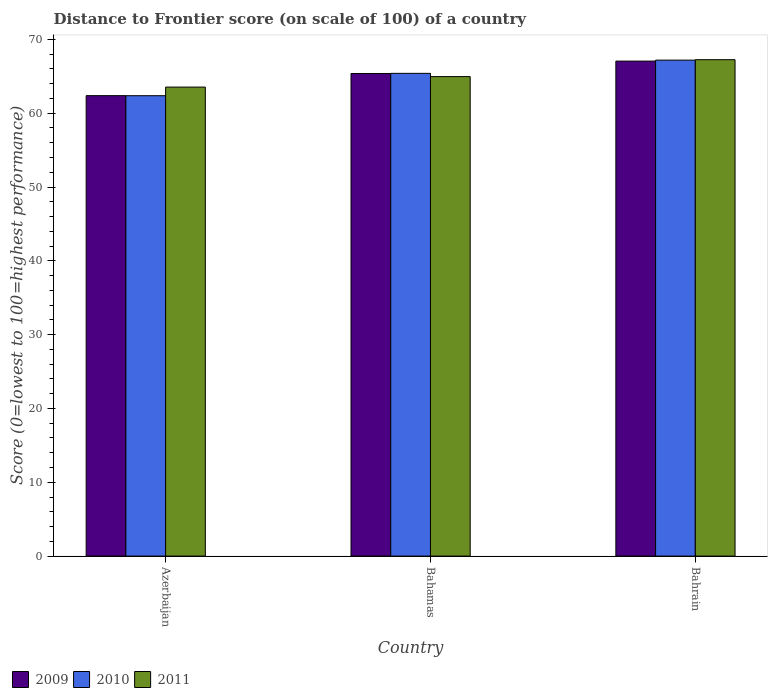How many different coloured bars are there?
Your answer should be very brief. 3. How many groups of bars are there?
Your answer should be very brief. 3. Are the number of bars per tick equal to the number of legend labels?
Give a very brief answer. Yes. Are the number of bars on each tick of the X-axis equal?
Offer a very short reply. Yes. How many bars are there on the 2nd tick from the left?
Ensure brevity in your answer.  3. How many bars are there on the 1st tick from the right?
Offer a very short reply. 3. What is the label of the 1st group of bars from the left?
Provide a succinct answer. Azerbaijan. What is the distance to frontier score of in 2009 in Bahrain?
Provide a succinct answer. 67.06. Across all countries, what is the maximum distance to frontier score of in 2011?
Offer a terse response. 67.25. Across all countries, what is the minimum distance to frontier score of in 2011?
Ensure brevity in your answer.  63.54. In which country was the distance to frontier score of in 2010 maximum?
Keep it short and to the point. Bahrain. In which country was the distance to frontier score of in 2011 minimum?
Ensure brevity in your answer.  Azerbaijan. What is the total distance to frontier score of in 2011 in the graph?
Keep it short and to the point. 195.75. What is the difference between the distance to frontier score of in 2010 in Azerbaijan and that in Bahamas?
Ensure brevity in your answer.  -3.03. What is the difference between the distance to frontier score of in 2011 in Bahrain and the distance to frontier score of in 2009 in Bahamas?
Your answer should be very brief. 1.87. What is the average distance to frontier score of in 2011 per country?
Keep it short and to the point. 65.25. What is the difference between the distance to frontier score of of/in 2010 and distance to frontier score of of/in 2009 in Azerbaijan?
Ensure brevity in your answer.  -0.01. What is the ratio of the distance to frontier score of in 2010 in Bahamas to that in Bahrain?
Provide a succinct answer. 0.97. Is the distance to frontier score of in 2009 in Azerbaijan less than that in Bahrain?
Make the answer very short. Yes. What is the difference between the highest and the second highest distance to frontier score of in 2009?
Offer a terse response. -1.68. What is the difference between the highest and the lowest distance to frontier score of in 2010?
Make the answer very short. 4.82. In how many countries, is the distance to frontier score of in 2010 greater than the average distance to frontier score of in 2010 taken over all countries?
Your answer should be compact. 2. Is the sum of the distance to frontier score of in 2011 in Bahamas and Bahrain greater than the maximum distance to frontier score of in 2010 across all countries?
Keep it short and to the point. Yes. What does the 2nd bar from the left in Azerbaijan represents?
Your answer should be compact. 2010. Is it the case that in every country, the sum of the distance to frontier score of in 2009 and distance to frontier score of in 2010 is greater than the distance to frontier score of in 2011?
Provide a short and direct response. Yes. Are all the bars in the graph horizontal?
Provide a short and direct response. No. Where does the legend appear in the graph?
Your response must be concise. Bottom left. How many legend labels are there?
Your answer should be very brief. 3. What is the title of the graph?
Your answer should be very brief. Distance to Frontier score (on scale of 100) of a country. Does "2009" appear as one of the legend labels in the graph?
Provide a succinct answer. Yes. What is the label or title of the X-axis?
Make the answer very short. Country. What is the label or title of the Y-axis?
Provide a short and direct response. Score (0=lowest to 100=highest performance). What is the Score (0=lowest to 100=highest performance) of 2009 in Azerbaijan?
Provide a short and direct response. 62.38. What is the Score (0=lowest to 100=highest performance) in 2010 in Azerbaijan?
Keep it short and to the point. 62.37. What is the Score (0=lowest to 100=highest performance) in 2011 in Azerbaijan?
Ensure brevity in your answer.  63.54. What is the Score (0=lowest to 100=highest performance) in 2009 in Bahamas?
Provide a succinct answer. 65.38. What is the Score (0=lowest to 100=highest performance) of 2010 in Bahamas?
Provide a short and direct response. 65.4. What is the Score (0=lowest to 100=highest performance) of 2011 in Bahamas?
Keep it short and to the point. 64.96. What is the Score (0=lowest to 100=highest performance) in 2009 in Bahrain?
Your response must be concise. 67.06. What is the Score (0=lowest to 100=highest performance) in 2010 in Bahrain?
Provide a short and direct response. 67.19. What is the Score (0=lowest to 100=highest performance) of 2011 in Bahrain?
Your answer should be compact. 67.25. Across all countries, what is the maximum Score (0=lowest to 100=highest performance) of 2009?
Provide a succinct answer. 67.06. Across all countries, what is the maximum Score (0=lowest to 100=highest performance) in 2010?
Provide a short and direct response. 67.19. Across all countries, what is the maximum Score (0=lowest to 100=highest performance) of 2011?
Ensure brevity in your answer.  67.25. Across all countries, what is the minimum Score (0=lowest to 100=highest performance) in 2009?
Ensure brevity in your answer.  62.38. Across all countries, what is the minimum Score (0=lowest to 100=highest performance) of 2010?
Give a very brief answer. 62.37. Across all countries, what is the minimum Score (0=lowest to 100=highest performance) in 2011?
Make the answer very short. 63.54. What is the total Score (0=lowest to 100=highest performance) of 2009 in the graph?
Your answer should be compact. 194.82. What is the total Score (0=lowest to 100=highest performance) of 2010 in the graph?
Ensure brevity in your answer.  194.96. What is the total Score (0=lowest to 100=highest performance) of 2011 in the graph?
Keep it short and to the point. 195.75. What is the difference between the Score (0=lowest to 100=highest performance) of 2010 in Azerbaijan and that in Bahamas?
Make the answer very short. -3.03. What is the difference between the Score (0=lowest to 100=highest performance) of 2011 in Azerbaijan and that in Bahamas?
Provide a short and direct response. -1.42. What is the difference between the Score (0=lowest to 100=highest performance) of 2009 in Azerbaijan and that in Bahrain?
Make the answer very short. -4.68. What is the difference between the Score (0=lowest to 100=highest performance) in 2010 in Azerbaijan and that in Bahrain?
Give a very brief answer. -4.82. What is the difference between the Score (0=lowest to 100=highest performance) of 2011 in Azerbaijan and that in Bahrain?
Provide a short and direct response. -3.71. What is the difference between the Score (0=lowest to 100=highest performance) in 2009 in Bahamas and that in Bahrain?
Provide a short and direct response. -1.68. What is the difference between the Score (0=lowest to 100=highest performance) of 2010 in Bahamas and that in Bahrain?
Provide a short and direct response. -1.79. What is the difference between the Score (0=lowest to 100=highest performance) of 2011 in Bahamas and that in Bahrain?
Your answer should be compact. -2.29. What is the difference between the Score (0=lowest to 100=highest performance) of 2009 in Azerbaijan and the Score (0=lowest to 100=highest performance) of 2010 in Bahamas?
Provide a succinct answer. -3.02. What is the difference between the Score (0=lowest to 100=highest performance) in 2009 in Azerbaijan and the Score (0=lowest to 100=highest performance) in 2011 in Bahamas?
Your answer should be compact. -2.58. What is the difference between the Score (0=lowest to 100=highest performance) of 2010 in Azerbaijan and the Score (0=lowest to 100=highest performance) of 2011 in Bahamas?
Ensure brevity in your answer.  -2.59. What is the difference between the Score (0=lowest to 100=highest performance) of 2009 in Azerbaijan and the Score (0=lowest to 100=highest performance) of 2010 in Bahrain?
Your answer should be very brief. -4.81. What is the difference between the Score (0=lowest to 100=highest performance) in 2009 in Azerbaijan and the Score (0=lowest to 100=highest performance) in 2011 in Bahrain?
Provide a short and direct response. -4.87. What is the difference between the Score (0=lowest to 100=highest performance) in 2010 in Azerbaijan and the Score (0=lowest to 100=highest performance) in 2011 in Bahrain?
Offer a very short reply. -4.88. What is the difference between the Score (0=lowest to 100=highest performance) of 2009 in Bahamas and the Score (0=lowest to 100=highest performance) of 2010 in Bahrain?
Ensure brevity in your answer.  -1.81. What is the difference between the Score (0=lowest to 100=highest performance) of 2009 in Bahamas and the Score (0=lowest to 100=highest performance) of 2011 in Bahrain?
Offer a terse response. -1.87. What is the difference between the Score (0=lowest to 100=highest performance) of 2010 in Bahamas and the Score (0=lowest to 100=highest performance) of 2011 in Bahrain?
Give a very brief answer. -1.85. What is the average Score (0=lowest to 100=highest performance) in 2009 per country?
Keep it short and to the point. 64.94. What is the average Score (0=lowest to 100=highest performance) in 2010 per country?
Keep it short and to the point. 64.99. What is the average Score (0=lowest to 100=highest performance) in 2011 per country?
Make the answer very short. 65.25. What is the difference between the Score (0=lowest to 100=highest performance) of 2009 and Score (0=lowest to 100=highest performance) of 2010 in Azerbaijan?
Give a very brief answer. 0.01. What is the difference between the Score (0=lowest to 100=highest performance) in 2009 and Score (0=lowest to 100=highest performance) in 2011 in Azerbaijan?
Your answer should be very brief. -1.16. What is the difference between the Score (0=lowest to 100=highest performance) of 2010 and Score (0=lowest to 100=highest performance) of 2011 in Azerbaijan?
Give a very brief answer. -1.17. What is the difference between the Score (0=lowest to 100=highest performance) of 2009 and Score (0=lowest to 100=highest performance) of 2010 in Bahamas?
Your answer should be compact. -0.02. What is the difference between the Score (0=lowest to 100=highest performance) in 2009 and Score (0=lowest to 100=highest performance) in 2011 in Bahamas?
Keep it short and to the point. 0.42. What is the difference between the Score (0=lowest to 100=highest performance) of 2010 and Score (0=lowest to 100=highest performance) of 2011 in Bahamas?
Provide a short and direct response. 0.44. What is the difference between the Score (0=lowest to 100=highest performance) in 2009 and Score (0=lowest to 100=highest performance) in 2010 in Bahrain?
Offer a very short reply. -0.13. What is the difference between the Score (0=lowest to 100=highest performance) in 2009 and Score (0=lowest to 100=highest performance) in 2011 in Bahrain?
Provide a succinct answer. -0.19. What is the difference between the Score (0=lowest to 100=highest performance) of 2010 and Score (0=lowest to 100=highest performance) of 2011 in Bahrain?
Offer a very short reply. -0.06. What is the ratio of the Score (0=lowest to 100=highest performance) in 2009 in Azerbaijan to that in Bahamas?
Give a very brief answer. 0.95. What is the ratio of the Score (0=lowest to 100=highest performance) in 2010 in Azerbaijan to that in Bahamas?
Ensure brevity in your answer.  0.95. What is the ratio of the Score (0=lowest to 100=highest performance) of 2011 in Azerbaijan to that in Bahamas?
Your answer should be very brief. 0.98. What is the ratio of the Score (0=lowest to 100=highest performance) of 2009 in Azerbaijan to that in Bahrain?
Your response must be concise. 0.93. What is the ratio of the Score (0=lowest to 100=highest performance) in 2010 in Azerbaijan to that in Bahrain?
Offer a terse response. 0.93. What is the ratio of the Score (0=lowest to 100=highest performance) in 2011 in Azerbaijan to that in Bahrain?
Make the answer very short. 0.94. What is the ratio of the Score (0=lowest to 100=highest performance) of 2009 in Bahamas to that in Bahrain?
Offer a terse response. 0.97. What is the ratio of the Score (0=lowest to 100=highest performance) in 2010 in Bahamas to that in Bahrain?
Offer a very short reply. 0.97. What is the ratio of the Score (0=lowest to 100=highest performance) in 2011 in Bahamas to that in Bahrain?
Keep it short and to the point. 0.97. What is the difference between the highest and the second highest Score (0=lowest to 100=highest performance) of 2009?
Your answer should be very brief. 1.68. What is the difference between the highest and the second highest Score (0=lowest to 100=highest performance) of 2010?
Provide a succinct answer. 1.79. What is the difference between the highest and the second highest Score (0=lowest to 100=highest performance) of 2011?
Provide a succinct answer. 2.29. What is the difference between the highest and the lowest Score (0=lowest to 100=highest performance) of 2009?
Your answer should be compact. 4.68. What is the difference between the highest and the lowest Score (0=lowest to 100=highest performance) in 2010?
Offer a very short reply. 4.82. What is the difference between the highest and the lowest Score (0=lowest to 100=highest performance) in 2011?
Make the answer very short. 3.71. 